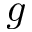Convert formula to latex. <formula><loc_0><loc_0><loc_500><loc_500>g</formula> 